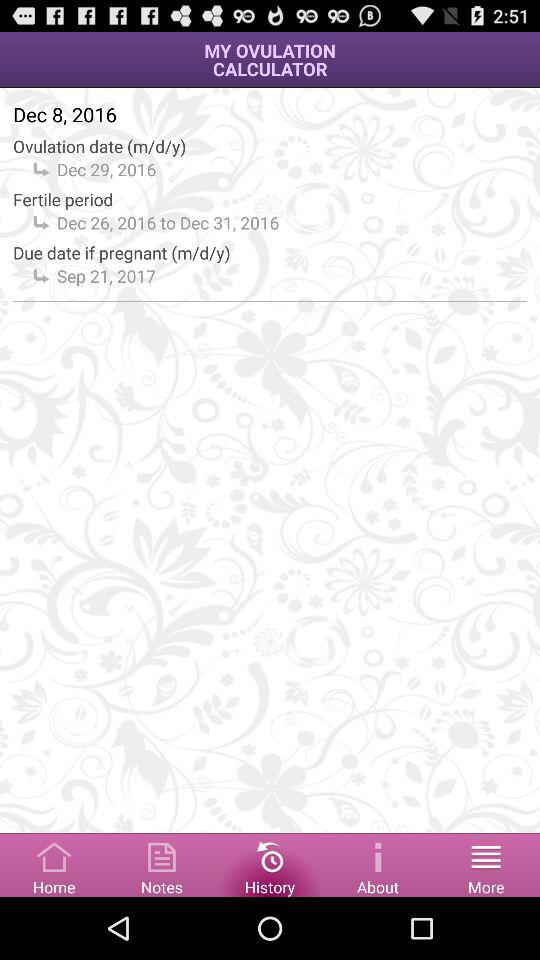How many days are between the start and end of the fertile period?
Answer the question using a single word or phrase. 5 